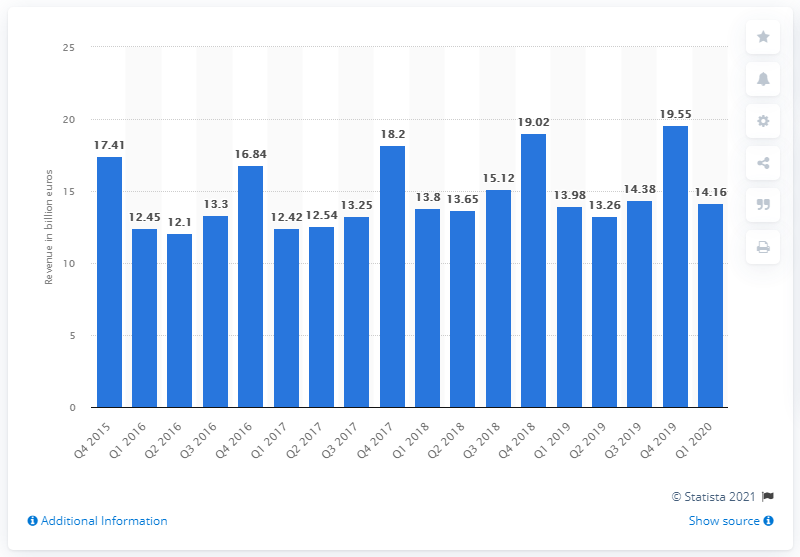Point out several critical features in this image. In the first quarter of 2020, the revenues from telecommunications consumer goods in Western Europe totaled 13.98 billion euros. 